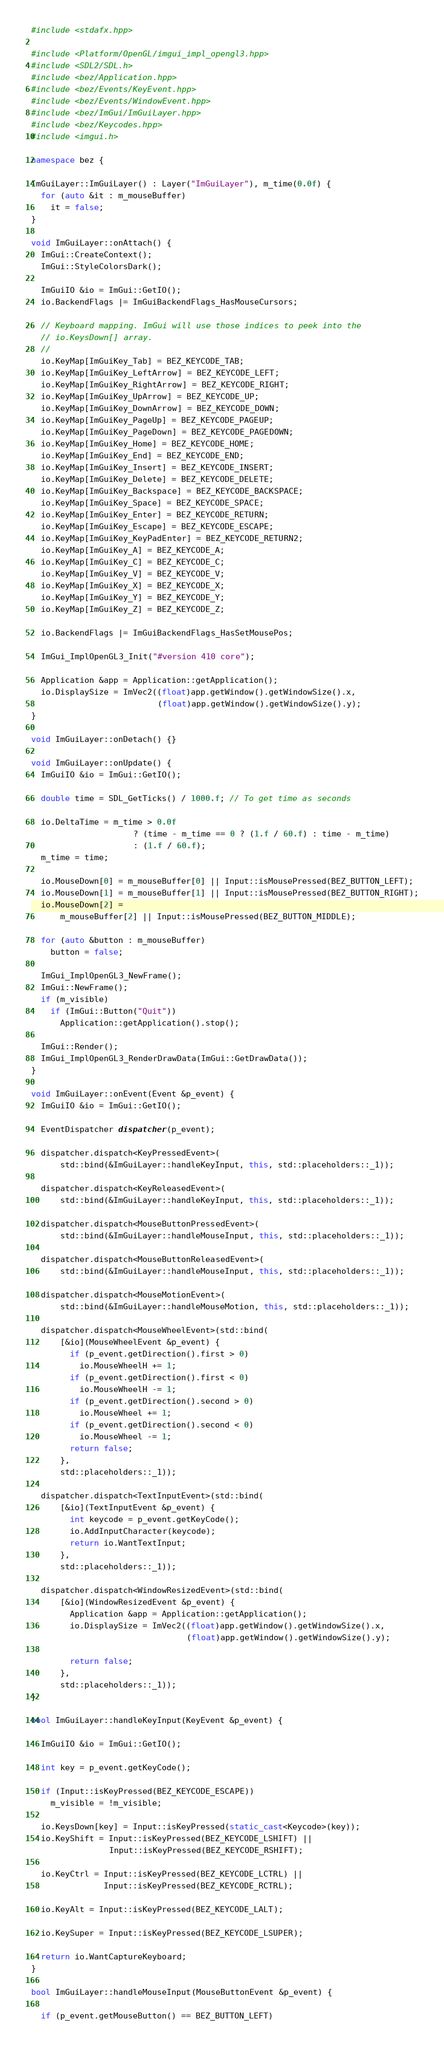<code> <loc_0><loc_0><loc_500><loc_500><_C++_>#include <stdafx.hpp>

#include <Platform/OpenGL/imgui_impl_opengl3.hpp>
#include <SDL2/SDL.h>
#include <bez/Application.hpp>
#include <bez/Events/KeyEvent.hpp>
#include <bez/Events/WindowEvent.hpp>
#include <bez/ImGui/ImGuiLayer.hpp>
#include <bez/Keycodes.hpp>
#include <imgui.h>

namespace bez {

ImGuiLayer::ImGuiLayer() : Layer("ImGuiLayer"), m_time(0.0f) {
  for (auto &it : m_mouseBuffer)
    it = false;
}

void ImGuiLayer::onAttach() {
  ImGui::CreateContext();
  ImGui::StyleColorsDark();

  ImGuiIO &io = ImGui::GetIO();
  io.BackendFlags |= ImGuiBackendFlags_HasMouseCursors;

  // Keyboard mapping. ImGui will use those indices to peek into the
  // io.KeysDown[] array.
  //
  io.KeyMap[ImGuiKey_Tab] = BEZ_KEYCODE_TAB;
  io.KeyMap[ImGuiKey_LeftArrow] = BEZ_KEYCODE_LEFT;
  io.KeyMap[ImGuiKey_RightArrow] = BEZ_KEYCODE_RIGHT;
  io.KeyMap[ImGuiKey_UpArrow] = BEZ_KEYCODE_UP;
  io.KeyMap[ImGuiKey_DownArrow] = BEZ_KEYCODE_DOWN;
  io.KeyMap[ImGuiKey_PageUp] = BEZ_KEYCODE_PAGEUP;
  io.KeyMap[ImGuiKey_PageDown] = BEZ_KEYCODE_PAGEDOWN;
  io.KeyMap[ImGuiKey_Home] = BEZ_KEYCODE_HOME;
  io.KeyMap[ImGuiKey_End] = BEZ_KEYCODE_END;
  io.KeyMap[ImGuiKey_Insert] = BEZ_KEYCODE_INSERT;
  io.KeyMap[ImGuiKey_Delete] = BEZ_KEYCODE_DELETE;
  io.KeyMap[ImGuiKey_Backspace] = BEZ_KEYCODE_BACKSPACE;
  io.KeyMap[ImGuiKey_Space] = BEZ_KEYCODE_SPACE;
  io.KeyMap[ImGuiKey_Enter] = BEZ_KEYCODE_RETURN;
  io.KeyMap[ImGuiKey_Escape] = BEZ_KEYCODE_ESCAPE;
  io.KeyMap[ImGuiKey_KeyPadEnter] = BEZ_KEYCODE_RETURN2;
  io.KeyMap[ImGuiKey_A] = BEZ_KEYCODE_A;
  io.KeyMap[ImGuiKey_C] = BEZ_KEYCODE_C;
  io.KeyMap[ImGuiKey_V] = BEZ_KEYCODE_V;
  io.KeyMap[ImGuiKey_X] = BEZ_KEYCODE_X;
  io.KeyMap[ImGuiKey_Y] = BEZ_KEYCODE_Y;
  io.KeyMap[ImGuiKey_Z] = BEZ_KEYCODE_Z;

  io.BackendFlags |= ImGuiBackendFlags_HasSetMousePos;

  ImGui_ImplOpenGL3_Init("#version 410 core");

  Application &app = Application::getApplication();
  io.DisplaySize = ImVec2((float)app.getWindow().getWindowSize().x,
                          (float)app.getWindow().getWindowSize().y);
}

void ImGuiLayer::onDetach() {}

void ImGuiLayer::onUpdate() {
  ImGuiIO &io = ImGui::GetIO();

  double time = SDL_GetTicks() / 1000.f; // To get time as seconds

  io.DeltaTime = m_time > 0.0f
                     ? (time - m_time == 0 ? (1.f / 60.f) : time - m_time)
                     : (1.f / 60.f);
  m_time = time;

  io.MouseDown[0] = m_mouseBuffer[0] || Input::isMousePressed(BEZ_BUTTON_LEFT);
  io.MouseDown[1] = m_mouseBuffer[1] || Input::isMousePressed(BEZ_BUTTON_RIGHT);
  io.MouseDown[2] =
      m_mouseBuffer[2] || Input::isMousePressed(BEZ_BUTTON_MIDDLE);

  for (auto &button : m_mouseBuffer)
    button = false;

  ImGui_ImplOpenGL3_NewFrame();
  ImGui::NewFrame();
  if (m_visible)
    if (ImGui::Button("Quit"))
      Application::getApplication().stop();

  ImGui::Render();
  ImGui_ImplOpenGL3_RenderDrawData(ImGui::GetDrawData());
}

void ImGuiLayer::onEvent(Event &p_event) {
  ImGuiIO &io = ImGui::GetIO();

  EventDispatcher dispatcher(p_event);

  dispatcher.dispatch<KeyPressedEvent>(
      std::bind(&ImGuiLayer::handleKeyInput, this, std::placeholders::_1));

  dispatcher.dispatch<KeyReleasedEvent>(
      std::bind(&ImGuiLayer::handleKeyInput, this, std::placeholders::_1));

  dispatcher.dispatch<MouseButtonPressedEvent>(
      std::bind(&ImGuiLayer::handleMouseInput, this, std::placeholders::_1));

  dispatcher.dispatch<MouseButtonReleasedEvent>(
      std::bind(&ImGuiLayer::handleMouseInput, this, std::placeholders::_1));

  dispatcher.dispatch<MouseMotionEvent>(
      std::bind(&ImGuiLayer::handleMouseMotion, this, std::placeholders::_1));

  dispatcher.dispatch<MouseWheelEvent>(std::bind(
      [&io](MouseWheelEvent &p_event) {
        if (p_event.getDirection().first > 0)
          io.MouseWheelH += 1;
        if (p_event.getDirection().first < 0)
          io.MouseWheelH -= 1;
        if (p_event.getDirection().second > 0)
          io.MouseWheel += 1;
        if (p_event.getDirection().second < 0)
          io.MouseWheel -= 1;
        return false;
      },
      std::placeholders::_1));

  dispatcher.dispatch<TextInputEvent>(std::bind(
      [&io](TextInputEvent &p_event) {
        int keycode = p_event.getKeyCode();
        io.AddInputCharacter(keycode);
        return io.WantTextInput;
      },
      std::placeholders::_1));

  dispatcher.dispatch<WindowResizedEvent>(std::bind(
      [&io](WindowResizedEvent &p_event) {
        Application &app = Application::getApplication();
        io.DisplaySize = ImVec2((float)app.getWindow().getWindowSize().x,
                                (float)app.getWindow().getWindowSize().y);

        return false;
      },
      std::placeholders::_1));
}

bool ImGuiLayer::handleKeyInput(KeyEvent &p_event) {

  ImGuiIO &io = ImGui::GetIO();

  int key = p_event.getKeyCode();

  if (Input::isKeyPressed(BEZ_KEYCODE_ESCAPE))
    m_visible = !m_visible;

  io.KeysDown[key] = Input::isKeyPressed(static_cast<Keycode>(key));
  io.KeyShift = Input::isKeyPressed(BEZ_KEYCODE_LSHIFT) ||
                Input::isKeyPressed(BEZ_KEYCODE_RSHIFT);

  io.KeyCtrl = Input::isKeyPressed(BEZ_KEYCODE_LCTRL) ||
               Input::isKeyPressed(BEZ_KEYCODE_RCTRL);

  io.KeyAlt = Input::isKeyPressed(BEZ_KEYCODE_LALT);

  io.KeySuper = Input::isKeyPressed(BEZ_KEYCODE_LSUPER);

  return io.WantCaptureKeyboard;
}

bool ImGuiLayer::handleMouseInput(MouseButtonEvent &p_event) {

  if (p_event.getMouseButton() == BEZ_BUTTON_LEFT)</code> 